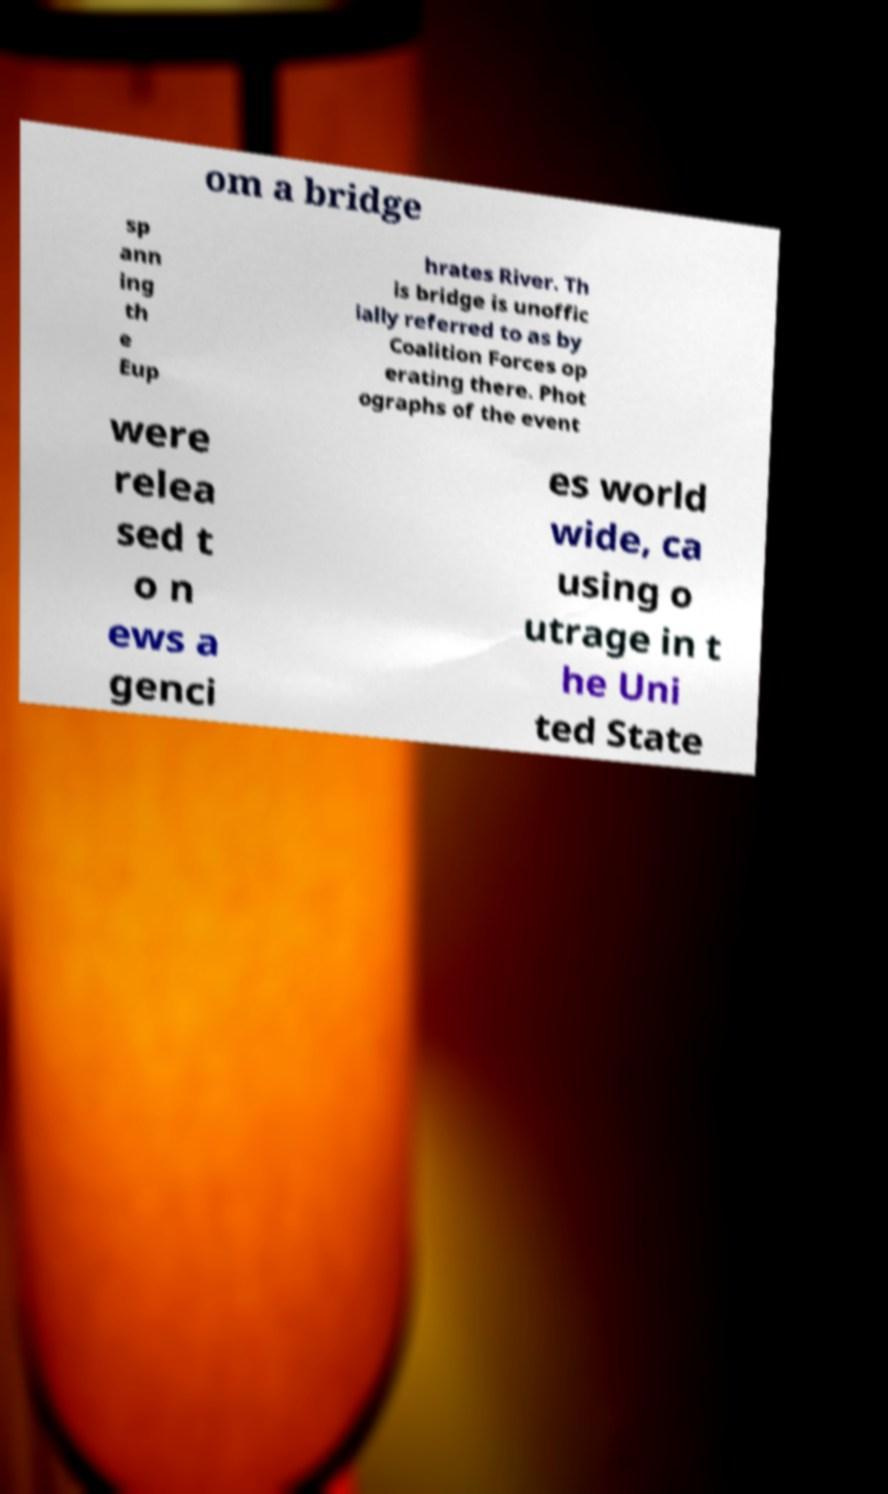I need the written content from this picture converted into text. Can you do that? om a bridge sp ann ing th e Eup hrates River. Th is bridge is unoffic ially referred to as by Coalition Forces op erating there. Phot ographs of the event were relea sed t o n ews a genci es world wide, ca using o utrage in t he Uni ted State 